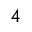Convert formula to latex. <formula><loc_0><loc_0><loc_500><loc_500>^ { 4 }</formula> 